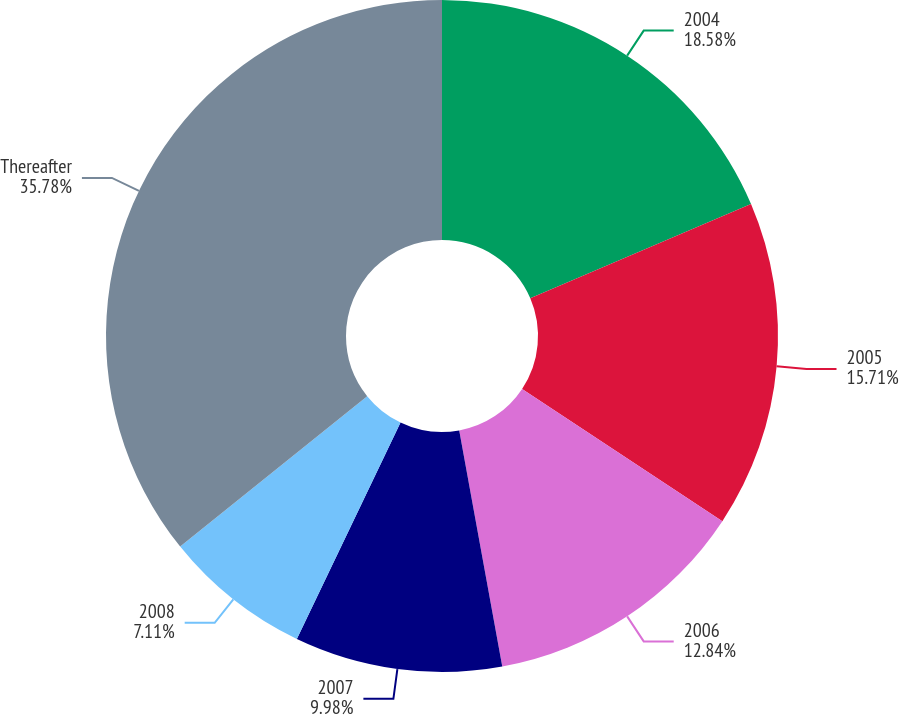Convert chart to OTSL. <chart><loc_0><loc_0><loc_500><loc_500><pie_chart><fcel>2004<fcel>2005<fcel>2006<fcel>2007<fcel>2008<fcel>Thereafter<nl><fcel>18.58%<fcel>15.71%<fcel>12.84%<fcel>9.98%<fcel>7.11%<fcel>35.78%<nl></chart> 